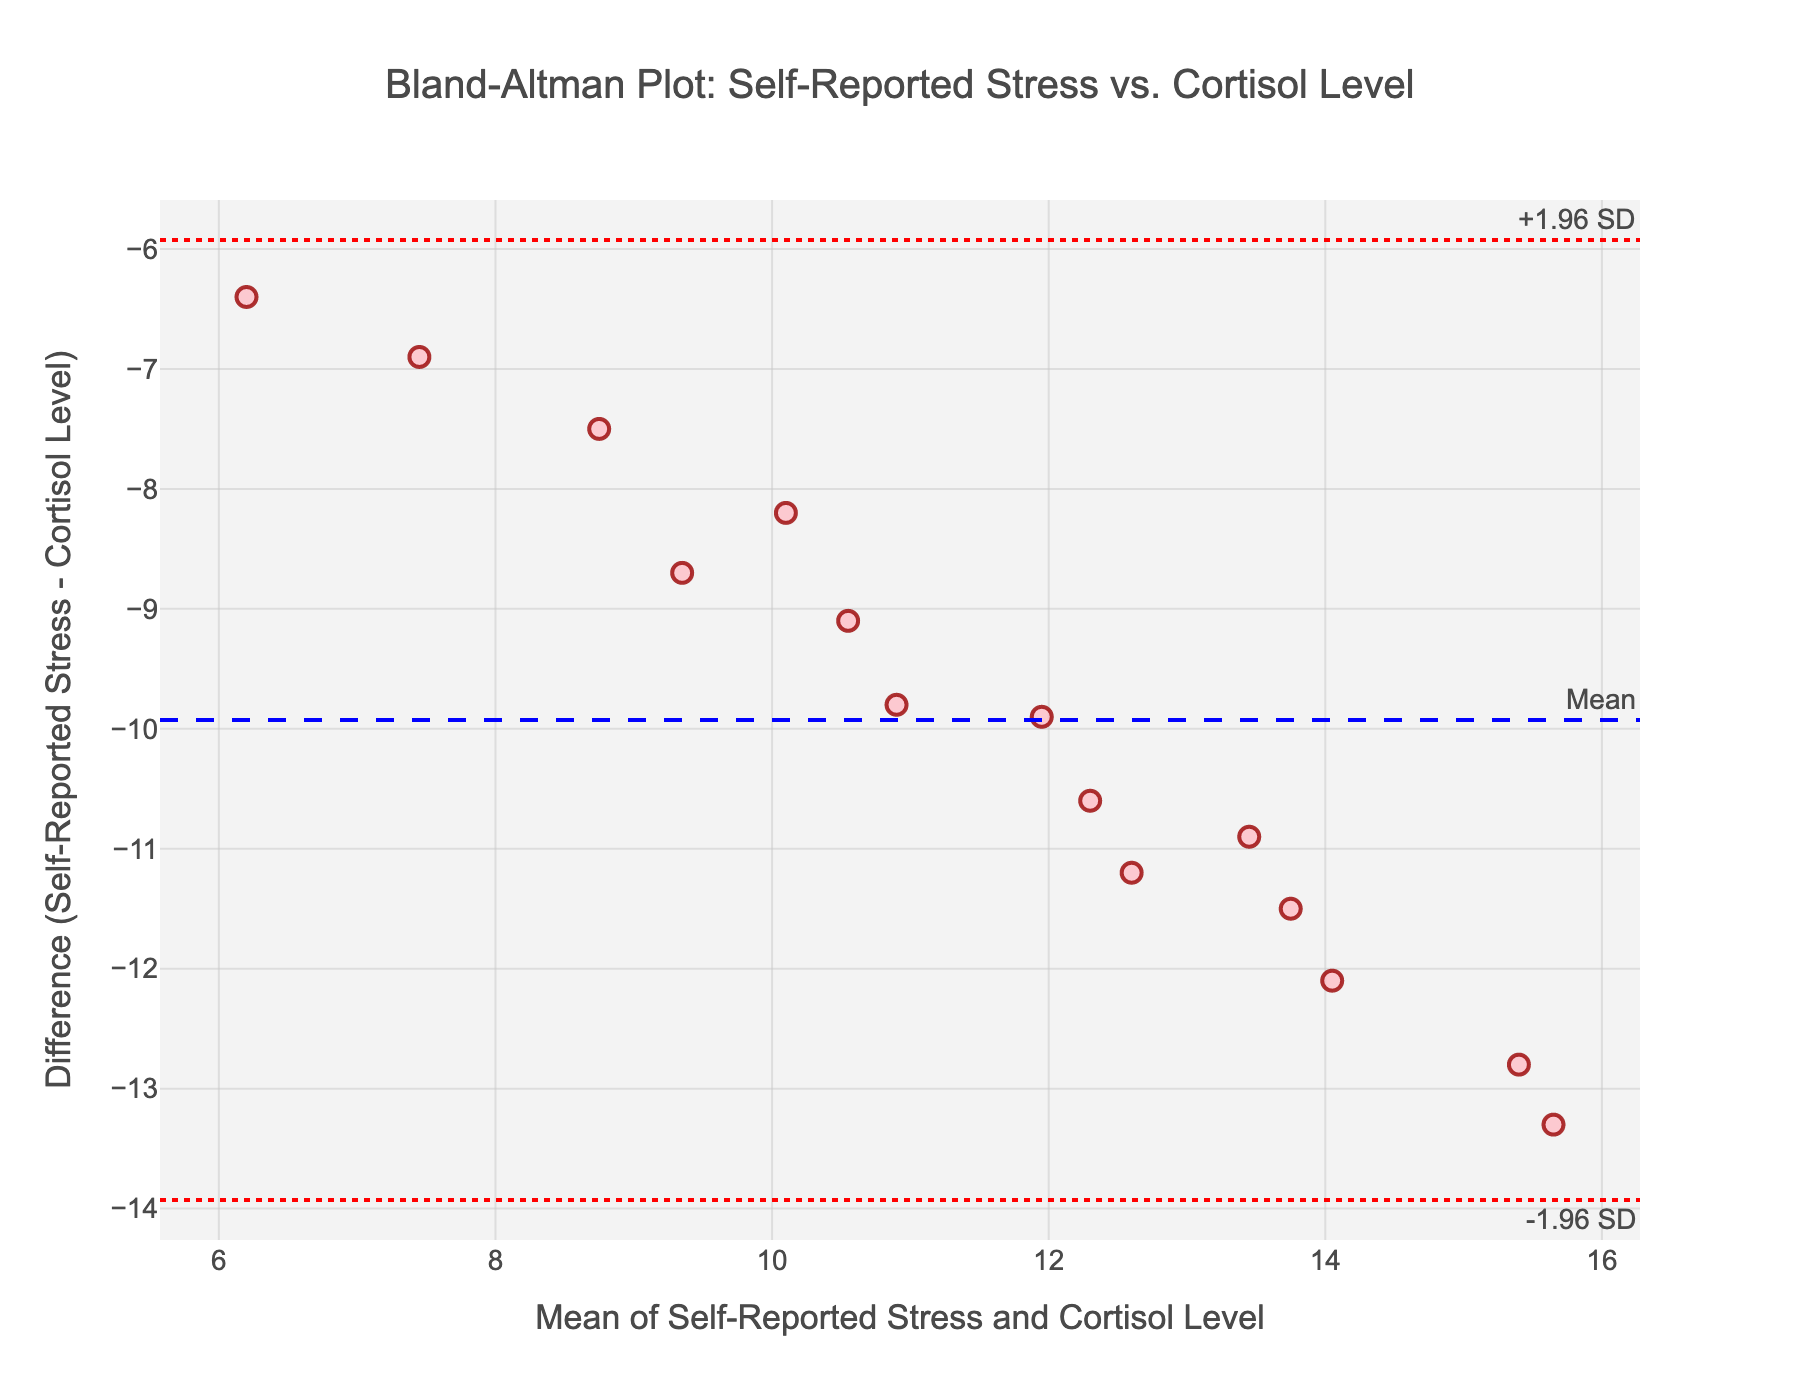What's the title of the plot? The title of the plot is prominently displayed at the top of the figure. It provides a brief description of what the plot represents.
Answer: Bland-Altman Plot: Self-Reported Stress vs. Cortisol Level What is the mean difference of self-reported stress and cortisol levels? The mean difference is indicated by the dashed blue line, annotated as "Mean."
Answer: (mean difference value from figure) What are the upper and lower limits of agreement in the plot? The upper limit of agreement is marked by the red dotted line annotated as "+1.96 SD," and the lower limit of agreement is marked by another red dotted line annotated as "-1.96 SD."
Answer: (upper limit value, lower limit value) How many data points are plotted in the Bland-Altman plot? The number of data points corresponds to the number of markers visible in the scatter plot.
Answer: 15 Which student has the highest difference between self-reported stress and cortisol level? To find the student with the highest difference, identify the data point that is farthest from the mean difference line in either direction.
Answer: (student's name with the highest difference) What is the mean of the self-reported stress and cortisol level for Taylor? Taylor's mean value is computed by averaging their self-reported stress value and cortisol level.
Answer: (mean value of Taylor) How does the mean difference relate to the majority of the data points? Assess the position of the majority of the data points in relation to the mean difference line to answer this question.
Answer: Most points are around the mean difference line Are there any significant outliers beyond the limits of agreement? Check for any data points that fall beyond the upper or lower red dotted lines, which represent the limits of agreement.
Answer: (Yes/No and number of outliers, if any) Which student has the closest mean of self-reported stress and cortisol level to the overall mean of the data? Calculate the mean for each student and compare these to the overall mean of all the data points to determine the closest.
Answer: (student's name) Is the variability between self-reported stress and cortisol levels homogeneous across different levels of means? Visually assess the spread of the data points across different levels of the mean to determine if variability is consistent.
Answer: (Yes/No and explanation) 